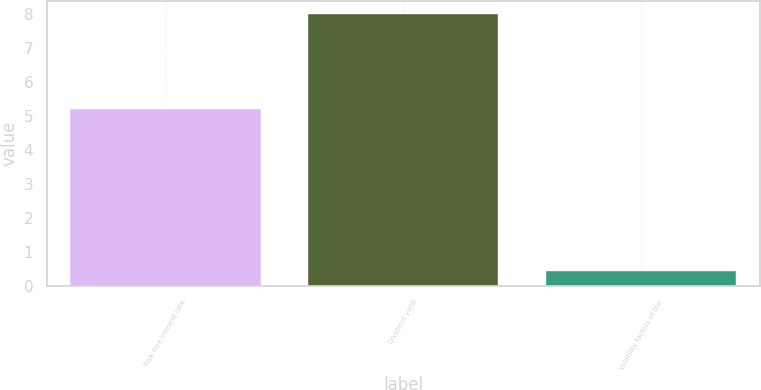<chart> <loc_0><loc_0><loc_500><loc_500><bar_chart><fcel>Risk free interest rate<fcel>Dividend yield<fcel>Volatility factors of the<nl><fcel>5.2<fcel>8<fcel>0.44<nl></chart> 